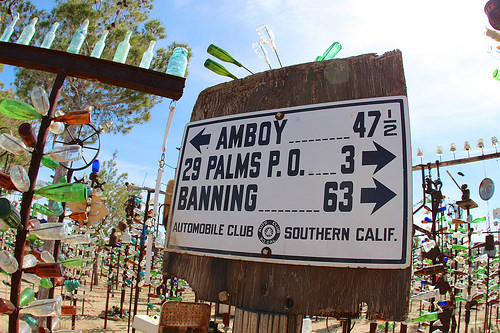<image>
Can you confirm if the sign is on the street? Yes. Looking at the image, I can see the sign is positioned on top of the street, with the street providing support. 